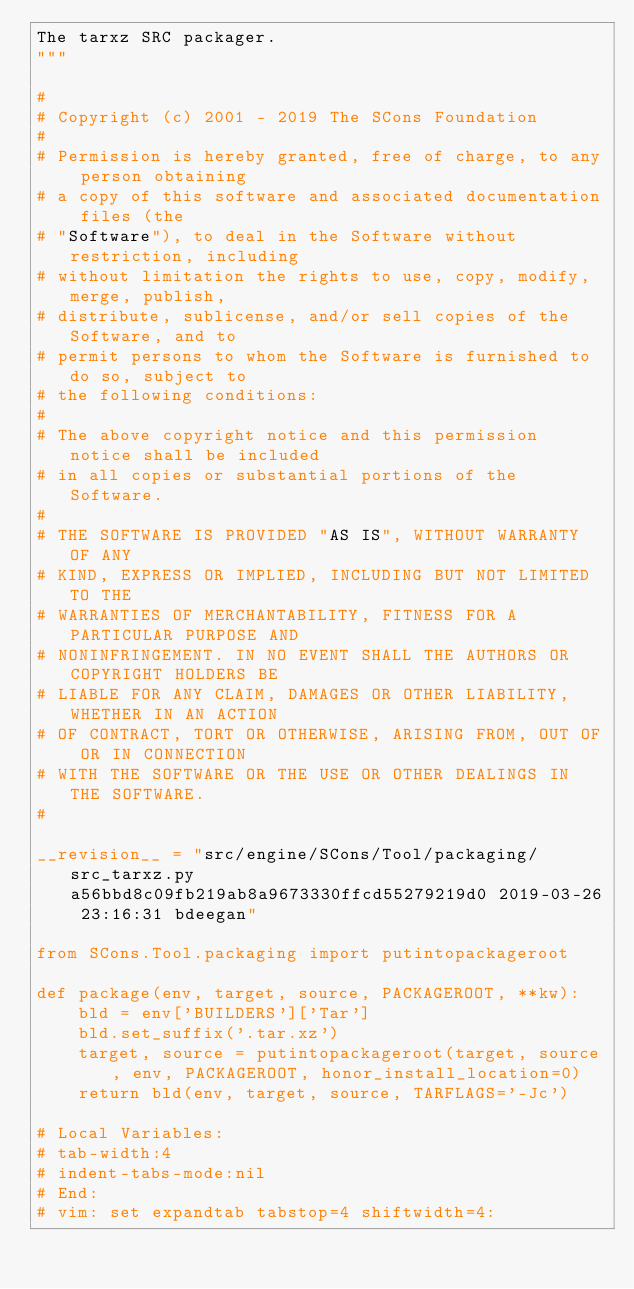Convert code to text. <code><loc_0><loc_0><loc_500><loc_500><_Python_>The tarxz SRC packager.
"""

#
# Copyright (c) 2001 - 2019 The SCons Foundation
#
# Permission is hereby granted, free of charge, to any person obtaining
# a copy of this software and associated documentation files (the
# "Software"), to deal in the Software without restriction, including
# without limitation the rights to use, copy, modify, merge, publish,
# distribute, sublicense, and/or sell copies of the Software, and to
# permit persons to whom the Software is furnished to do so, subject to
# the following conditions:
#
# The above copyright notice and this permission notice shall be included
# in all copies or substantial portions of the Software.
#
# THE SOFTWARE IS PROVIDED "AS IS", WITHOUT WARRANTY OF ANY
# KIND, EXPRESS OR IMPLIED, INCLUDING BUT NOT LIMITED TO THE
# WARRANTIES OF MERCHANTABILITY, FITNESS FOR A PARTICULAR PURPOSE AND
# NONINFRINGEMENT. IN NO EVENT SHALL THE AUTHORS OR COPYRIGHT HOLDERS BE
# LIABLE FOR ANY CLAIM, DAMAGES OR OTHER LIABILITY, WHETHER IN AN ACTION
# OF CONTRACT, TORT OR OTHERWISE, ARISING FROM, OUT OF OR IN CONNECTION
# WITH THE SOFTWARE OR THE USE OR OTHER DEALINGS IN THE SOFTWARE.
#

__revision__ = "src/engine/SCons/Tool/packaging/src_tarxz.py a56bbd8c09fb219ab8a9673330ffcd55279219d0 2019-03-26 23:16:31 bdeegan"

from SCons.Tool.packaging import putintopackageroot

def package(env, target, source, PACKAGEROOT, **kw):
    bld = env['BUILDERS']['Tar']
    bld.set_suffix('.tar.xz')
    target, source = putintopackageroot(target, source, env, PACKAGEROOT, honor_install_location=0)
    return bld(env, target, source, TARFLAGS='-Jc')

# Local Variables:
# tab-width:4
# indent-tabs-mode:nil
# End:
# vim: set expandtab tabstop=4 shiftwidth=4:
</code> 